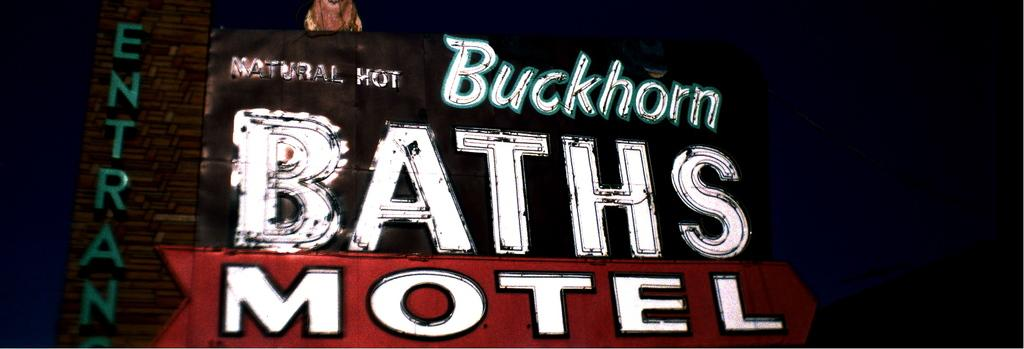<image>
Render a clear and concise summary of the photo. the top of a motel with a sign that says 'buckhorn baths motel' 